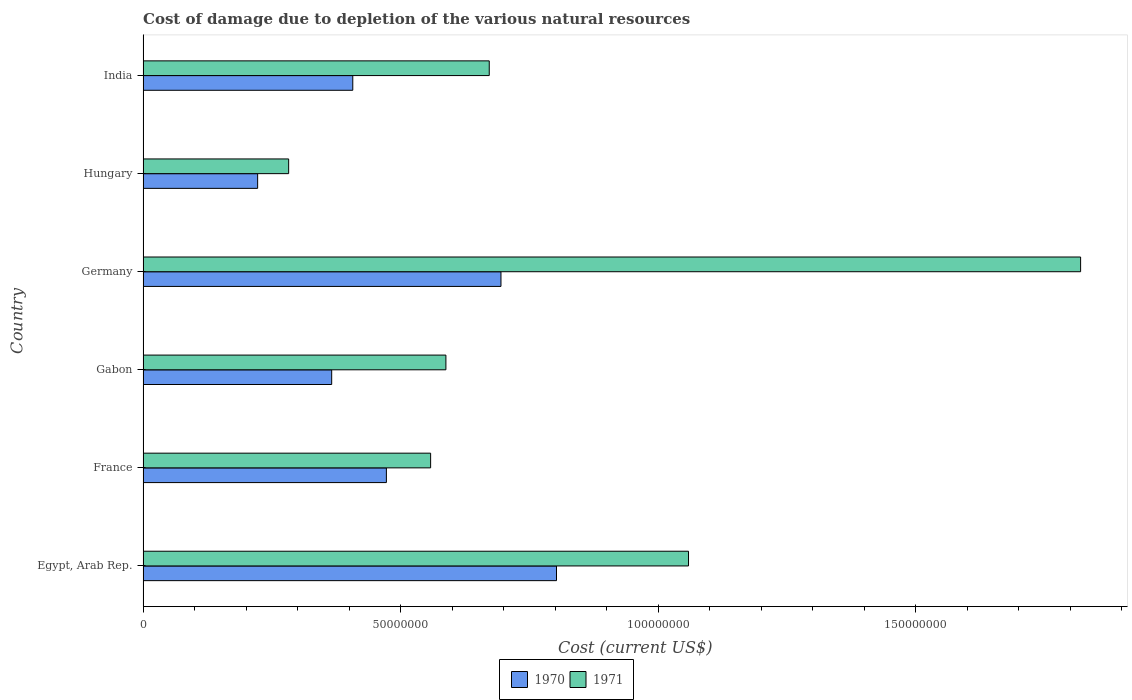How many different coloured bars are there?
Give a very brief answer. 2. Are the number of bars per tick equal to the number of legend labels?
Your answer should be very brief. Yes. Are the number of bars on each tick of the Y-axis equal?
Provide a succinct answer. Yes. How many bars are there on the 3rd tick from the bottom?
Your answer should be compact. 2. What is the label of the 6th group of bars from the top?
Your answer should be compact. Egypt, Arab Rep. In how many cases, is the number of bars for a given country not equal to the number of legend labels?
Offer a very short reply. 0. What is the cost of damage caused due to the depletion of various natural resources in 1971 in Hungary?
Your answer should be compact. 2.83e+07. Across all countries, what is the maximum cost of damage caused due to the depletion of various natural resources in 1971?
Provide a succinct answer. 1.82e+08. Across all countries, what is the minimum cost of damage caused due to the depletion of various natural resources in 1970?
Give a very brief answer. 2.22e+07. In which country was the cost of damage caused due to the depletion of various natural resources in 1970 maximum?
Provide a short and direct response. Egypt, Arab Rep. In which country was the cost of damage caused due to the depletion of various natural resources in 1971 minimum?
Ensure brevity in your answer.  Hungary. What is the total cost of damage caused due to the depletion of various natural resources in 1970 in the graph?
Provide a short and direct response. 2.97e+08. What is the difference between the cost of damage caused due to the depletion of various natural resources in 1970 in Egypt, Arab Rep. and that in Germany?
Offer a very short reply. 1.08e+07. What is the difference between the cost of damage caused due to the depletion of various natural resources in 1970 in India and the cost of damage caused due to the depletion of various natural resources in 1971 in Germany?
Your response must be concise. -1.41e+08. What is the average cost of damage caused due to the depletion of various natural resources in 1970 per country?
Your response must be concise. 4.94e+07. What is the difference between the cost of damage caused due to the depletion of various natural resources in 1971 and cost of damage caused due to the depletion of various natural resources in 1970 in India?
Make the answer very short. 2.65e+07. In how many countries, is the cost of damage caused due to the depletion of various natural resources in 1971 greater than 180000000 US$?
Offer a terse response. 1. What is the ratio of the cost of damage caused due to the depletion of various natural resources in 1970 in Gabon to that in Hungary?
Your answer should be compact. 1.65. What is the difference between the highest and the second highest cost of damage caused due to the depletion of various natural resources in 1971?
Offer a very short reply. 7.61e+07. What is the difference between the highest and the lowest cost of damage caused due to the depletion of various natural resources in 1971?
Your answer should be very brief. 1.54e+08. Is the sum of the cost of damage caused due to the depletion of various natural resources in 1970 in Egypt, Arab Rep. and France greater than the maximum cost of damage caused due to the depletion of various natural resources in 1971 across all countries?
Your response must be concise. No. What does the 2nd bar from the top in Germany represents?
Offer a terse response. 1970. How many bars are there?
Your response must be concise. 12. Are all the bars in the graph horizontal?
Keep it short and to the point. Yes. Does the graph contain grids?
Make the answer very short. No. Where does the legend appear in the graph?
Keep it short and to the point. Bottom center. What is the title of the graph?
Ensure brevity in your answer.  Cost of damage due to depletion of the various natural resources. Does "1974" appear as one of the legend labels in the graph?
Your answer should be compact. No. What is the label or title of the X-axis?
Your answer should be compact. Cost (current US$). What is the Cost (current US$) of 1970 in Egypt, Arab Rep.?
Your response must be concise. 8.02e+07. What is the Cost (current US$) in 1971 in Egypt, Arab Rep.?
Make the answer very short. 1.06e+08. What is the Cost (current US$) in 1970 in France?
Provide a short and direct response. 4.72e+07. What is the Cost (current US$) in 1971 in France?
Provide a short and direct response. 5.58e+07. What is the Cost (current US$) in 1970 in Gabon?
Your answer should be compact. 3.66e+07. What is the Cost (current US$) in 1971 in Gabon?
Provide a short and direct response. 5.88e+07. What is the Cost (current US$) in 1970 in Germany?
Make the answer very short. 6.95e+07. What is the Cost (current US$) of 1971 in Germany?
Your answer should be very brief. 1.82e+08. What is the Cost (current US$) of 1970 in Hungary?
Make the answer very short. 2.22e+07. What is the Cost (current US$) of 1971 in Hungary?
Offer a very short reply. 2.83e+07. What is the Cost (current US$) in 1970 in India?
Offer a very short reply. 4.07e+07. What is the Cost (current US$) of 1971 in India?
Your response must be concise. 6.72e+07. Across all countries, what is the maximum Cost (current US$) of 1970?
Your answer should be compact. 8.02e+07. Across all countries, what is the maximum Cost (current US$) in 1971?
Your response must be concise. 1.82e+08. Across all countries, what is the minimum Cost (current US$) of 1970?
Make the answer very short. 2.22e+07. Across all countries, what is the minimum Cost (current US$) in 1971?
Provide a succinct answer. 2.83e+07. What is the total Cost (current US$) in 1970 in the graph?
Offer a terse response. 2.97e+08. What is the total Cost (current US$) of 1971 in the graph?
Make the answer very short. 4.98e+08. What is the difference between the Cost (current US$) of 1970 in Egypt, Arab Rep. and that in France?
Ensure brevity in your answer.  3.30e+07. What is the difference between the Cost (current US$) of 1971 in Egypt, Arab Rep. and that in France?
Offer a terse response. 5.01e+07. What is the difference between the Cost (current US$) of 1970 in Egypt, Arab Rep. and that in Gabon?
Ensure brevity in your answer.  4.36e+07. What is the difference between the Cost (current US$) of 1971 in Egypt, Arab Rep. and that in Gabon?
Your answer should be very brief. 4.71e+07. What is the difference between the Cost (current US$) of 1970 in Egypt, Arab Rep. and that in Germany?
Give a very brief answer. 1.08e+07. What is the difference between the Cost (current US$) of 1971 in Egypt, Arab Rep. and that in Germany?
Your answer should be very brief. -7.61e+07. What is the difference between the Cost (current US$) in 1970 in Egypt, Arab Rep. and that in Hungary?
Offer a terse response. 5.80e+07. What is the difference between the Cost (current US$) of 1971 in Egypt, Arab Rep. and that in Hungary?
Provide a succinct answer. 7.76e+07. What is the difference between the Cost (current US$) of 1970 in Egypt, Arab Rep. and that in India?
Your answer should be compact. 3.95e+07. What is the difference between the Cost (current US$) of 1971 in Egypt, Arab Rep. and that in India?
Your response must be concise. 3.87e+07. What is the difference between the Cost (current US$) in 1970 in France and that in Gabon?
Provide a short and direct response. 1.06e+07. What is the difference between the Cost (current US$) of 1971 in France and that in Gabon?
Make the answer very short. -2.96e+06. What is the difference between the Cost (current US$) of 1970 in France and that in Germany?
Offer a terse response. -2.22e+07. What is the difference between the Cost (current US$) of 1971 in France and that in Germany?
Your answer should be very brief. -1.26e+08. What is the difference between the Cost (current US$) of 1970 in France and that in Hungary?
Provide a short and direct response. 2.50e+07. What is the difference between the Cost (current US$) in 1971 in France and that in Hungary?
Provide a succinct answer. 2.76e+07. What is the difference between the Cost (current US$) of 1970 in France and that in India?
Make the answer very short. 6.53e+06. What is the difference between the Cost (current US$) in 1971 in France and that in India?
Offer a very short reply. -1.14e+07. What is the difference between the Cost (current US$) in 1970 in Gabon and that in Germany?
Keep it short and to the point. -3.29e+07. What is the difference between the Cost (current US$) of 1971 in Gabon and that in Germany?
Ensure brevity in your answer.  -1.23e+08. What is the difference between the Cost (current US$) of 1970 in Gabon and that in Hungary?
Your answer should be compact. 1.44e+07. What is the difference between the Cost (current US$) in 1971 in Gabon and that in Hungary?
Offer a very short reply. 3.05e+07. What is the difference between the Cost (current US$) in 1970 in Gabon and that in India?
Give a very brief answer. -4.09e+06. What is the difference between the Cost (current US$) in 1971 in Gabon and that in India?
Ensure brevity in your answer.  -8.41e+06. What is the difference between the Cost (current US$) of 1970 in Germany and that in Hungary?
Provide a short and direct response. 4.72e+07. What is the difference between the Cost (current US$) of 1971 in Germany and that in Hungary?
Your answer should be compact. 1.54e+08. What is the difference between the Cost (current US$) in 1970 in Germany and that in India?
Offer a terse response. 2.88e+07. What is the difference between the Cost (current US$) in 1971 in Germany and that in India?
Your answer should be compact. 1.15e+08. What is the difference between the Cost (current US$) of 1970 in Hungary and that in India?
Make the answer very short. -1.85e+07. What is the difference between the Cost (current US$) of 1971 in Hungary and that in India?
Provide a short and direct response. -3.89e+07. What is the difference between the Cost (current US$) in 1970 in Egypt, Arab Rep. and the Cost (current US$) in 1971 in France?
Provide a short and direct response. 2.44e+07. What is the difference between the Cost (current US$) of 1970 in Egypt, Arab Rep. and the Cost (current US$) of 1971 in Gabon?
Keep it short and to the point. 2.15e+07. What is the difference between the Cost (current US$) of 1970 in Egypt, Arab Rep. and the Cost (current US$) of 1971 in Germany?
Your answer should be compact. -1.02e+08. What is the difference between the Cost (current US$) in 1970 in Egypt, Arab Rep. and the Cost (current US$) in 1971 in Hungary?
Keep it short and to the point. 5.20e+07. What is the difference between the Cost (current US$) in 1970 in Egypt, Arab Rep. and the Cost (current US$) in 1971 in India?
Offer a terse response. 1.31e+07. What is the difference between the Cost (current US$) in 1970 in France and the Cost (current US$) in 1971 in Gabon?
Your answer should be compact. -1.15e+07. What is the difference between the Cost (current US$) in 1970 in France and the Cost (current US$) in 1971 in Germany?
Give a very brief answer. -1.35e+08. What is the difference between the Cost (current US$) of 1970 in France and the Cost (current US$) of 1971 in Hungary?
Make the answer very short. 1.90e+07. What is the difference between the Cost (current US$) of 1970 in France and the Cost (current US$) of 1971 in India?
Offer a terse response. -2.00e+07. What is the difference between the Cost (current US$) of 1970 in Gabon and the Cost (current US$) of 1971 in Germany?
Ensure brevity in your answer.  -1.45e+08. What is the difference between the Cost (current US$) of 1970 in Gabon and the Cost (current US$) of 1971 in Hungary?
Give a very brief answer. 8.35e+06. What is the difference between the Cost (current US$) in 1970 in Gabon and the Cost (current US$) in 1971 in India?
Your answer should be compact. -3.06e+07. What is the difference between the Cost (current US$) of 1970 in Germany and the Cost (current US$) of 1971 in Hungary?
Provide a short and direct response. 4.12e+07. What is the difference between the Cost (current US$) of 1970 in Germany and the Cost (current US$) of 1971 in India?
Your response must be concise. 2.27e+06. What is the difference between the Cost (current US$) in 1970 in Hungary and the Cost (current US$) in 1971 in India?
Provide a short and direct response. -4.50e+07. What is the average Cost (current US$) in 1970 per country?
Your answer should be very brief. 4.94e+07. What is the average Cost (current US$) of 1971 per country?
Offer a terse response. 8.30e+07. What is the difference between the Cost (current US$) in 1970 and Cost (current US$) in 1971 in Egypt, Arab Rep.?
Provide a succinct answer. -2.56e+07. What is the difference between the Cost (current US$) of 1970 and Cost (current US$) of 1971 in France?
Offer a terse response. -8.59e+06. What is the difference between the Cost (current US$) in 1970 and Cost (current US$) in 1971 in Gabon?
Provide a succinct answer. -2.22e+07. What is the difference between the Cost (current US$) of 1970 and Cost (current US$) of 1971 in Germany?
Your answer should be very brief. -1.13e+08. What is the difference between the Cost (current US$) in 1970 and Cost (current US$) in 1971 in Hungary?
Keep it short and to the point. -6.02e+06. What is the difference between the Cost (current US$) of 1970 and Cost (current US$) of 1971 in India?
Provide a succinct answer. -2.65e+07. What is the ratio of the Cost (current US$) in 1970 in Egypt, Arab Rep. to that in France?
Offer a terse response. 1.7. What is the ratio of the Cost (current US$) in 1971 in Egypt, Arab Rep. to that in France?
Provide a succinct answer. 1.9. What is the ratio of the Cost (current US$) of 1970 in Egypt, Arab Rep. to that in Gabon?
Offer a terse response. 2.19. What is the ratio of the Cost (current US$) of 1971 in Egypt, Arab Rep. to that in Gabon?
Your answer should be compact. 1.8. What is the ratio of the Cost (current US$) of 1970 in Egypt, Arab Rep. to that in Germany?
Provide a short and direct response. 1.16. What is the ratio of the Cost (current US$) of 1971 in Egypt, Arab Rep. to that in Germany?
Offer a terse response. 0.58. What is the ratio of the Cost (current US$) in 1970 in Egypt, Arab Rep. to that in Hungary?
Keep it short and to the point. 3.61. What is the ratio of the Cost (current US$) in 1971 in Egypt, Arab Rep. to that in Hungary?
Your response must be concise. 3.75. What is the ratio of the Cost (current US$) of 1970 in Egypt, Arab Rep. to that in India?
Make the answer very short. 1.97. What is the ratio of the Cost (current US$) in 1971 in Egypt, Arab Rep. to that in India?
Your answer should be compact. 1.58. What is the ratio of the Cost (current US$) in 1970 in France to that in Gabon?
Make the answer very short. 1.29. What is the ratio of the Cost (current US$) in 1971 in France to that in Gabon?
Offer a terse response. 0.95. What is the ratio of the Cost (current US$) in 1970 in France to that in Germany?
Offer a terse response. 0.68. What is the ratio of the Cost (current US$) in 1971 in France to that in Germany?
Give a very brief answer. 0.31. What is the ratio of the Cost (current US$) in 1970 in France to that in Hungary?
Your response must be concise. 2.12. What is the ratio of the Cost (current US$) of 1971 in France to that in Hungary?
Ensure brevity in your answer.  1.98. What is the ratio of the Cost (current US$) in 1970 in France to that in India?
Your response must be concise. 1.16. What is the ratio of the Cost (current US$) of 1971 in France to that in India?
Offer a very short reply. 0.83. What is the ratio of the Cost (current US$) in 1970 in Gabon to that in Germany?
Provide a succinct answer. 0.53. What is the ratio of the Cost (current US$) of 1971 in Gabon to that in Germany?
Make the answer very short. 0.32. What is the ratio of the Cost (current US$) in 1970 in Gabon to that in Hungary?
Your answer should be very brief. 1.65. What is the ratio of the Cost (current US$) in 1971 in Gabon to that in Hungary?
Your response must be concise. 2.08. What is the ratio of the Cost (current US$) of 1970 in Gabon to that in India?
Provide a short and direct response. 0.9. What is the ratio of the Cost (current US$) in 1971 in Gabon to that in India?
Provide a short and direct response. 0.87. What is the ratio of the Cost (current US$) of 1970 in Germany to that in Hungary?
Give a very brief answer. 3.12. What is the ratio of the Cost (current US$) in 1971 in Germany to that in Hungary?
Your answer should be very brief. 6.44. What is the ratio of the Cost (current US$) in 1970 in Germany to that in India?
Offer a terse response. 1.71. What is the ratio of the Cost (current US$) in 1971 in Germany to that in India?
Provide a succinct answer. 2.71. What is the ratio of the Cost (current US$) in 1970 in Hungary to that in India?
Provide a succinct answer. 0.55. What is the ratio of the Cost (current US$) in 1971 in Hungary to that in India?
Your answer should be very brief. 0.42. What is the difference between the highest and the second highest Cost (current US$) of 1970?
Your answer should be very brief. 1.08e+07. What is the difference between the highest and the second highest Cost (current US$) of 1971?
Make the answer very short. 7.61e+07. What is the difference between the highest and the lowest Cost (current US$) in 1970?
Make the answer very short. 5.80e+07. What is the difference between the highest and the lowest Cost (current US$) in 1971?
Make the answer very short. 1.54e+08. 